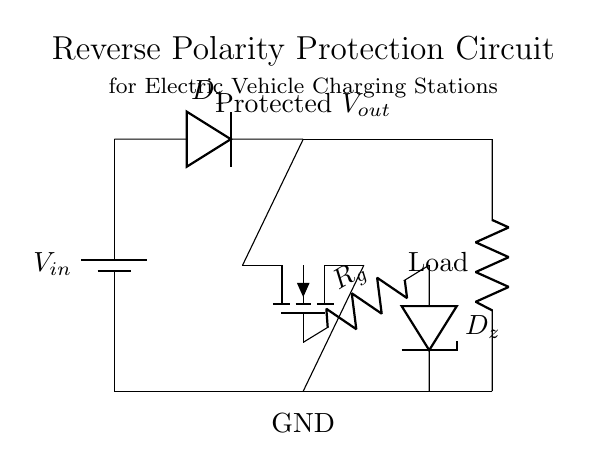What is the main function of the diode in this circuit? The diode serves the function of reverse polarity protection, allowing current to flow in only one direction and blocking reverse current that could damage the system.
Answer: reverse polarity protection What type of loads can be connected to this circuit? The circuit diagram indicates a generic load symbol, suggesting it can support any compatible loads typical for electric vehicle charging, such as batteries or electric motors.
Answer: electric vehicle loads What component protects against voltage spikes or fluctuations? The Zener diode (D z) is used to clamp voltage spikes, ensuring the output voltage remains stable and protecting the load from overvoltage conditions.
Answer: Zener diode How is the gate of the MOSFET controlled in this design? The MOSFET gate is controlled through a resistor (R g), which limits the current to ensure proper switching behavior and stability.
Answer: resistor What happens if the input voltage is reversed? If the input voltage is reversed, the diode will prevent current flow, protecting downstream components from potential damage due to reverse polarity.
Answer: no current flow What is the significance of the ground connection in this circuit? The ground connection establishes a common reference point for the circuit, ensuring safe operation and proper functioning of the components by completing the electrical circuit.
Answer: common reference point 